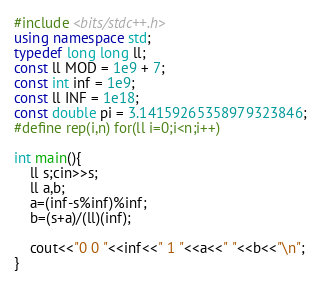<code> <loc_0><loc_0><loc_500><loc_500><_C++_>#include <bits/stdc++.h>
using namespace std;
typedef long long ll;
const ll MOD = 1e9 + 7;
const int inf = 1e9;
const ll INF = 1e18;
const double pi = 3.14159265358979323846;
#define rep(i,n) for(ll i=0;i<n;i++)

int main(){
	ll s;cin>>s;
	ll a,b;
	a=(inf-s%inf)%inf;
	b=(s+a)/(ll)(inf);

	cout<<"0 0 "<<inf<<" 1 "<<a<<" "<<b<<"\n";
}</code> 